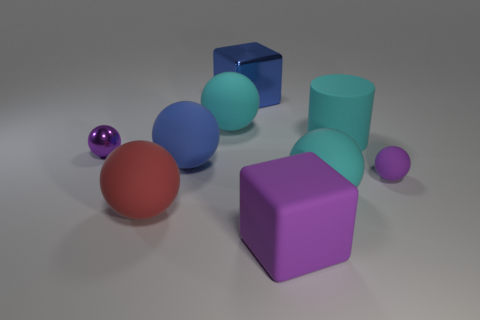What is the size of the cyan rubber thing in front of the large blue rubber sphere?
Give a very brief answer. Large. How big is the blue matte object?
Your answer should be very brief. Large. There is a cyan cylinder; is it the same size as the cyan ball on the right side of the large blue cube?
Provide a short and direct response. Yes. The block that is in front of the tiny purple ball that is to the right of the large cylinder is what color?
Make the answer very short. Purple. Is the number of large blue blocks in front of the blue sphere the same as the number of blue shiny cubes that are to the right of the red rubber object?
Make the answer very short. No. Does the purple sphere that is in front of the purple metallic ball have the same material as the cyan cylinder?
Provide a succinct answer. Yes. What is the color of the object that is both on the left side of the blue cube and behind the cyan cylinder?
Your response must be concise. Cyan. There is a large cyan object left of the big purple matte thing; how many big red balls are in front of it?
Provide a succinct answer. 1. There is another large thing that is the same shape as the blue metal object; what is its material?
Keep it short and to the point. Rubber. What is the color of the metallic cube?
Keep it short and to the point. Blue. 